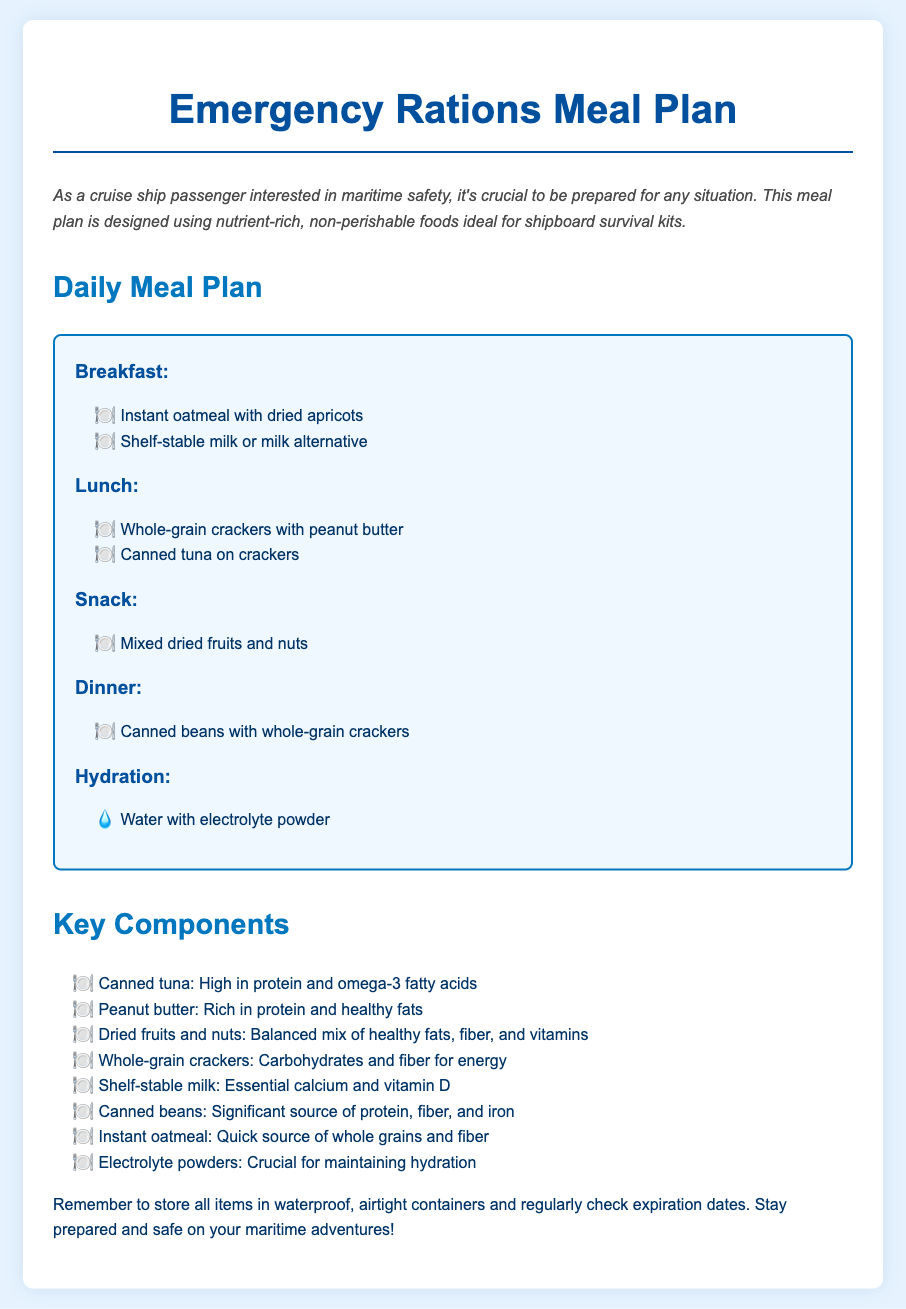what is the title of the document? The title appears at the top of the document and is "Emergency Rations Meal Plan".
Answer: Emergency Rations Meal Plan how many meals are listed in the daily meal plan? The daily meal plan includes four meals: Breakfast, Lunch, Snack, and Dinner.
Answer: Four what food is suggested for breakfast? In the breakfast section, instant oatmeal with dried apricots and shelf-stable milk or milk alternative are listed.
Answer: Instant oatmeal with dried apricots which food item is emphasized for hydration? The hydration section specifies the use of water mixed with electrolyte powder.
Answer: Water with electrolyte powder what is a key component of the meal plan that provides protein? The document lists canned tuna as a high protein component of the meal plan.
Answer: Canned tuna which item contributes calcium and vitamin D? The key component section mentions shelf-stable milk as an essential source of calcium and vitamin D.
Answer: Shelf-stable milk what type of nuts are included as a snack? The snack portion notes mixed dried fruits and nuts as a suggested item.
Answer: Mixed dried fruits and nuts which meal plan item can be categorized as a carbohydrate source? Whole-grain crackers are identified as a source of carbohydrates and fiber.
Answer: Whole-grain crackers 